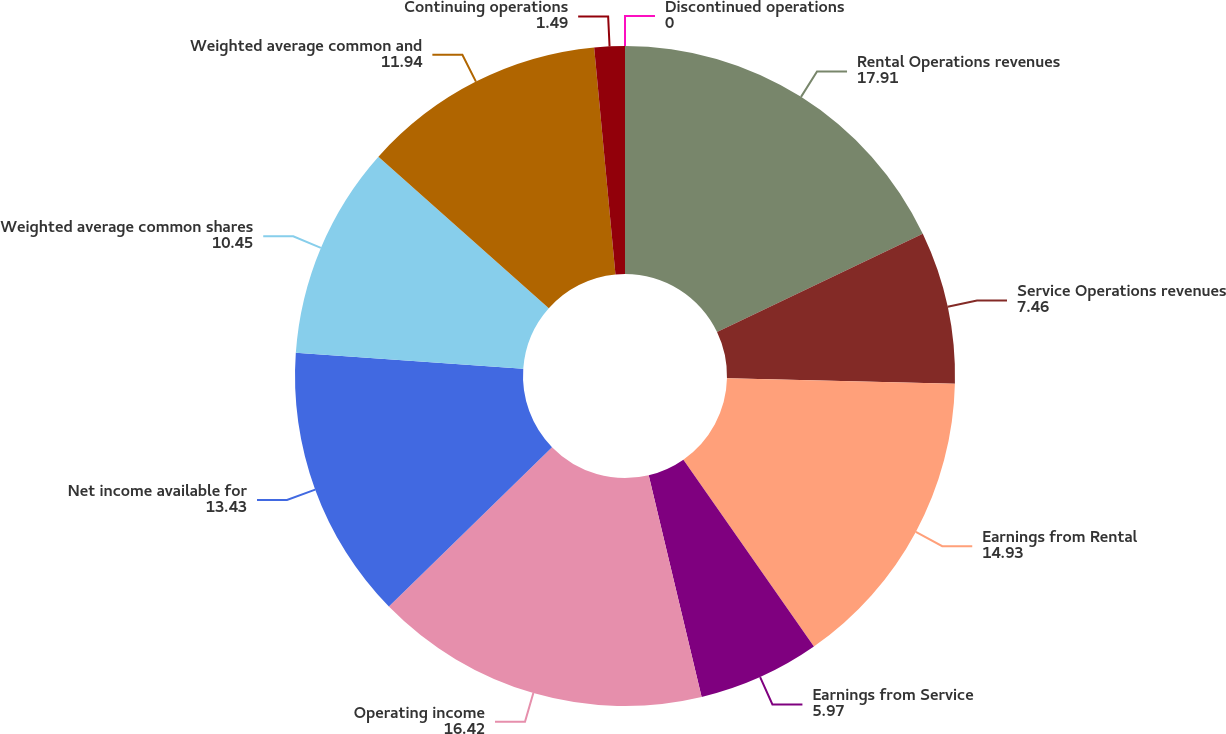<chart> <loc_0><loc_0><loc_500><loc_500><pie_chart><fcel>Rental Operations revenues<fcel>Service Operations revenues<fcel>Earnings from Rental<fcel>Earnings from Service<fcel>Operating income<fcel>Net income available for<fcel>Weighted average common shares<fcel>Weighted average common and<fcel>Continuing operations<fcel>Discontinued operations<nl><fcel>17.91%<fcel>7.46%<fcel>14.93%<fcel>5.97%<fcel>16.42%<fcel>13.43%<fcel>10.45%<fcel>11.94%<fcel>1.49%<fcel>0.0%<nl></chart> 